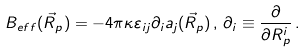<formula> <loc_0><loc_0><loc_500><loc_500>B _ { e f f } ( \vec { R } _ { p } ) = - 4 \pi \kappa \varepsilon _ { i j } \partial _ { i } a _ { j } ( \vec { R } _ { p } ) \, , \, \partial _ { i } \equiv \frac { \partial } { \partial R _ { p } ^ { i } } \, .</formula> 